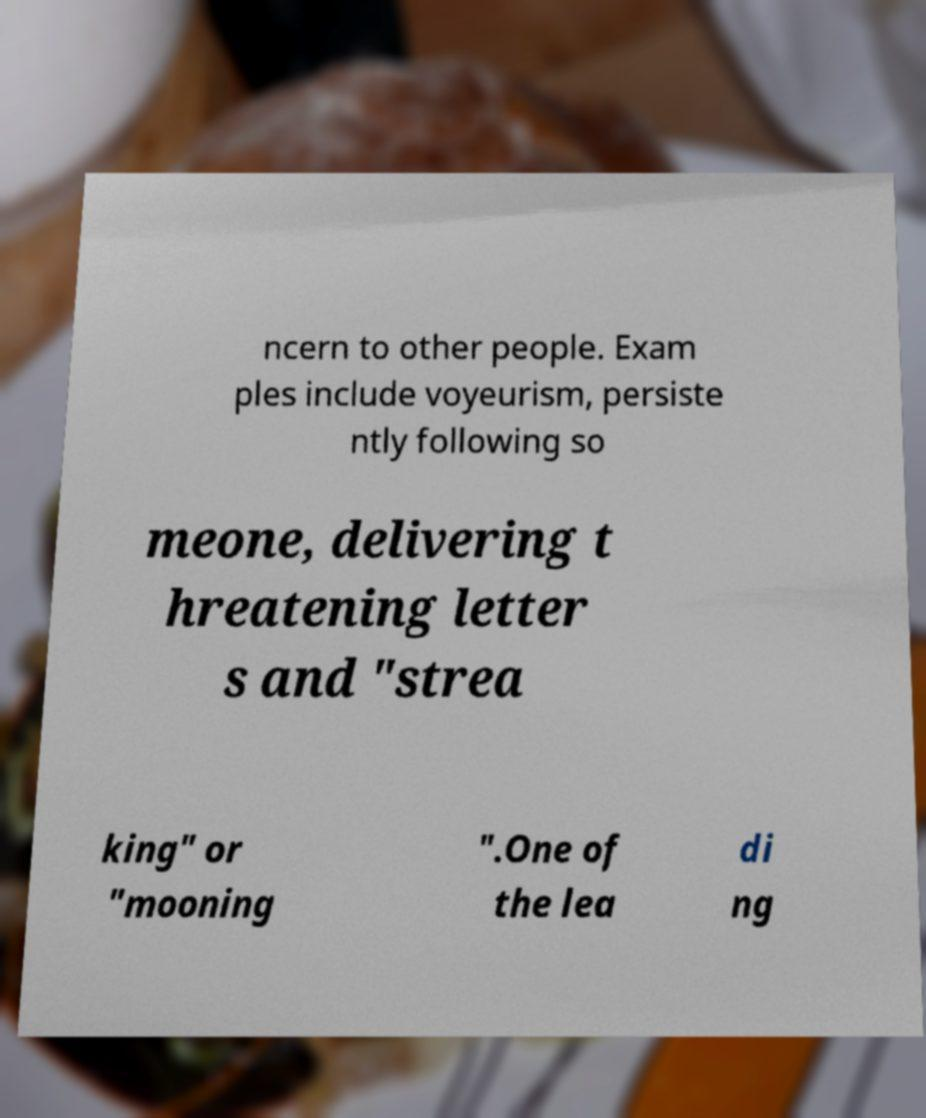Can you read and provide the text displayed in the image?This photo seems to have some interesting text. Can you extract and type it out for me? ncern to other people. Exam ples include voyeurism, persiste ntly following so meone, delivering t hreatening letter s and "strea king" or "mooning ".One of the lea di ng 